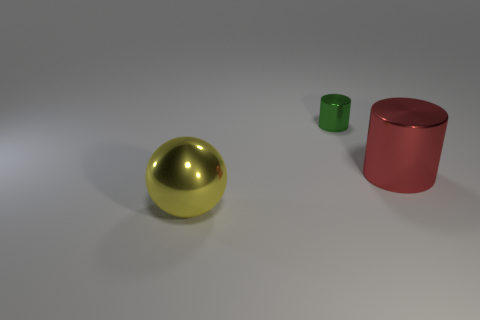What material is the thing that is in front of the big thing right of the large yellow shiny thing that is in front of the tiny metallic thing?
Your answer should be compact. Metal. What is the color of the shiny object in front of the large object that is behind the large yellow metal ball?
Your response must be concise. Yellow. What is the color of the shiny thing that is the same size as the red cylinder?
Your answer should be very brief. Yellow. What number of small objects are yellow metal objects or red cylinders?
Offer a terse response. 0. Is the number of cylinders that are behind the big red cylinder greater than the number of tiny objects that are behind the tiny metal cylinder?
Provide a succinct answer. Yes. What number of other things are there of the same size as the yellow object?
Your response must be concise. 1. Does the object that is to the right of the green shiny cylinder have the same material as the green cylinder?
Your answer should be compact. Yes. What number of other objects are the same color as the tiny shiny cylinder?
Provide a short and direct response. 0. What number of other things are the same shape as the big yellow object?
Your answer should be very brief. 0. There is a large metal thing on the right side of the large shiny ball; does it have the same shape as the large thing in front of the large red shiny cylinder?
Your response must be concise. No. 